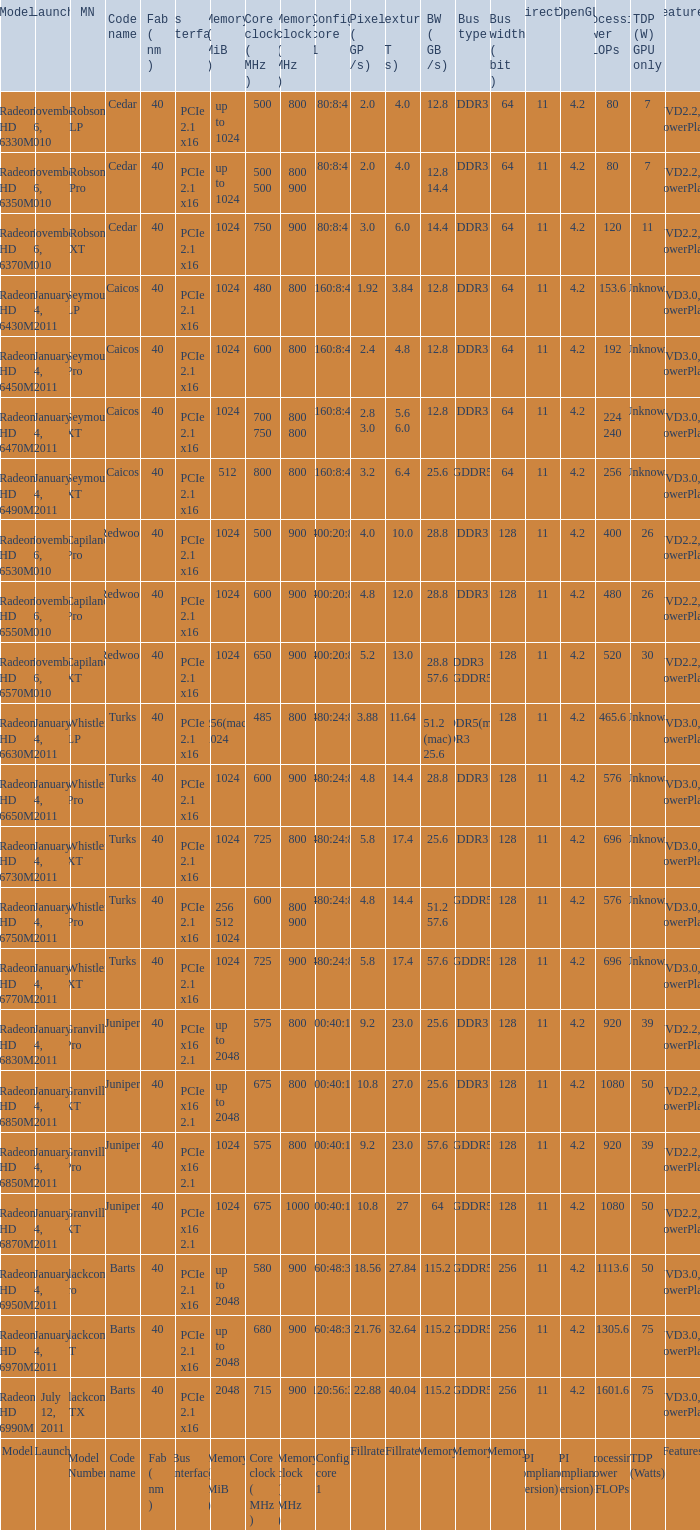Parse the full table. {'header': ['Model', 'Launch', 'MN', 'Code name', 'Fab ( nm )', 'Bus interface', 'Memory ( MiB )', 'Core clock ( MHz )', 'Memory clock ( MHz )', 'Config core 1', 'Pixel ( GP /s)', 'Texture ( GT /s)', 'BW ( GB /s)', 'Bus type', 'Bus width ( bit )', 'DirectX', 'OpenGL', 'Processing Power GFLOPs', 'TDP (W) GPU only', 'Features'], 'rows': [['Radeon HD 6330M', 'November 26, 2010', 'Robson LP', 'Cedar', '40', 'PCIe 2.1 x16', 'up to 1024', '500', '800', '80:8:4', '2.0', '4.0', '12.8', 'DDR3', '64', '11', '4.2', '80', '7', 'UVD2.2, PowerPlay'], ['Radeon HD 6350M', 'November 26, 2010', 'Robson Pro', 'Cedar', '40', 'PCIe 2.1 x16', 'up to 1024', '500 500', '800 900', '80:8:4', '2.0', '4.0', '12.8 14.4', 'DDR3', '64', '11', '4.2', '80', '7', 'UVD2.2, PowerPlay'], ['Radeon HD 6370M', 'November 26, 2010', 'Robson XT', 'Cedar', '40', 'PCIe 2.1 x16', '1024', '750', '900', '80:8:4', '3.0', '6.0', '14.4', 'DDR3', '64', '11', '4.2', '120', '11', 'UVD2.2, PowerPlay'], ['Radeon HD 6430M', 'January 4, 2011', 'Seymour LP', 'Caicos', '40', 'PCIe 2.1 x16', '1024', '480', '800', '160:8:4', '1.92', '3.84', '12.8', 'DDR3', '64', '11', '4.2', '153.6', 'Unknown', 'UVD3.0, PowerPlay'], ['Radeon HD 6450M', 'January 4, 2011', 'Seymour Pro', 'Caicos', '40', 'PCIe 2.1 x16', '1024', '600', '800', '160:8:4', '2.4', '4.8', '12.8', 'DDR3', '64', '11', '4.2', '192', 'Unknown', 'UVD3.0, PowerPlay'], ['Radeon HD 6470M', 'January 4, 2011', 'Seymour XT', 'Caicos', '40', 'PCIe 2.1 x16', '1024', '700 750', '800 800', '160:8:4', '2.8 3.0', '5.6 6.0', '12.8', 'DDR3', '64', '11', '4.2', '224 240', 'Unknown', 'UVD3.0, PowerPlay'], ['Radeon HD 6490M', 'January 4, 2011', 'Seymour XT', 'Caicos', '40', 'PCIe 2.1 x16', '512', '800', '800', '160:8:4', '3.2', '6.4', '25.6', 'GDDR5', '64', '11', '4.2', '256', 'Unknown', 'UVD3.0, PowerPlay'], ['Radeon HD 6530M', 'November 26, 2010', 'Capilano Pro', 'Redwood', '40', 'PCIe 2.1 x16', '1024', '500', '900', '400:20:8', '4.0', '10.0', '28.8', 'DDR3', '128', '11', '4.2', '400', '26', 'UVD2.2, PowerPlay'], ['Radeon HD 6550M', 'November 26, 2010', 'Capilano Pro', 'Redwood', '40', 'PCIe 2.1 x16', '1024', '600', '900', '400:20:8', '4.8', '12.0', '28.8', 'DDR3', '128', '11', '4.2', '480', '26', 'UVD2.2, PowerPlay'], ['Radeon HD 6570M', 'November 26, 2010', 'Capilano XT', 'Redwood', '40', 'PCIe 2.1 x16', '1024', '650', '900', '400:20:8', '5.2', '13.0', '28.8 57.6', 'DDR3 GDDR5', '128', '11', '4.2', '520', '30', 'UVD2.2, PowerPlay'], ['Radeon HD 6630M', 'January 4, 2011', 'Whistler LP', 'Turks', '40', 'PCIe 2.1 x16', '256(mac) 1024', '485', '800', '480:24:8', '3.88', '11.64', '51.2 (mac) 25.6', 'GDDR5(mac) DDR3', '128', '11', '4.2', '465.6', 'Unknown', 'UVD3.0, PowerPlay'], ['Radeon HD 6650M', 'January 4, 2011', 'Whistler Pro', 'Turks', '40', 'PCIe 2.1 x16', '1024', '600', '900', '480:24:8', '4.8', '14.4', '28.8', 'DDR3', '128', '11', '4.2', '576', 'Unknown', 'UVD3.0, PowerPlay'], ['Radeon HD 6730M', 'January 4, 2011', 'Whistler XT', 'Turks', '40', 'PCIe 2.1 x16', '1024', '725', '800', '480:24:8', '5.8', '17.4', '25.6', 'DDR3', '128', '11', '4.2', '696', 'Unknown', 'UVD3.0, PowerPlay'], ['Radeon HD 6750M', 'January 4, 2011', 'Whistler Pro', 'Turks', '40', 'PCIe 2.1 x16', '256 512 1024', '600', '800 900', '480:24:8', '4.8', '14.4', '51.2 57.6', 'GDDR5', '128', '11', '4.2', '576', 'Unknown', 'UVD3.0, PowerPlay'], ['Radeon HD 6770M', 'January 4, 2011', 'Whistler XT', 'Turks', '40', 'PCIe 2.1 x16', '1024', '725', '900', '480:24:8', '5.8', '17.4', '57.6', 'GDDR5', '128', '11', '4.2', '696', 'Unknown', 'UVD3.0, PowerPlay'], ['Radeon HD 6830M', 'January 4, 2011', 'Granville Pro', 'Juniper', '40', 'PCIe x16 2.1', 'up to 2048', '575', '800', '800:40:16', '9.2', '23.0', '25.6', 'DDR3', '128', '11', '4.2', '920', '39', 'UVD2.2, PowerPlay'], ['Radeon HD 6850M', 'January 4, 2011', 'Granville XT', 'Juniper', '40', 'PCIe x16 2.1', 'up to 2048', '675', '800', '800:40:16', '10.8', '27.0', '25.6', 'DDR3', '128', '11', '4.2', '1080', '50', 'UVD2.2, PowerPlay'], ['Radeon HD 6850M', 'January 4, 2011', 'Granville Pro', 'Juniper', '40', 'PCIe x16 2.1', '1024', '575', '800', '800:40:16', '9.2', '23.0', '57.6', 'GDDR5', '128', '11', '4.2', '920', '39', 'UVD2.2, PowerPlay'], ['Radeon HD 6870M', 'January 4, 2011', 'Granville XT', 'Juniper', '40', 'PCIe x16 2.1', '1024', '675', '1000', '800:40:16', '10.8', '27', '64', 'GDDR5', '128', '11', '4.2', '1080', '50', 'UVD2.2, PowerPlay'], ['Radeon HD 6950M', 'January 4, 2011', 'Blackcomb Pro', 'Barts', '40', 'PCIe 2.1 x16', 'up to 2048', '580', '900', '960:48:32', '18.56', '27.84', '115.2', 'GDDR5', '256', '11', '4.2', '1113.6', '50', 'UVD3.0, PowerPlay'], ['Radeon HD 6970M', 'January 4, 2011', 'Blackcomb XT', 'Barts', '40', 'PCIe 2.1 x16', 'up to 2048', '680', '900', '960:48:32', '21.76', '32.64', '115.2', 'GDDR5', '256', '11', '4.2', '1305.6', '75', 'UVD3.0, PowerPlay'], ['Radeon HD 6990M', 'July 12, 2011', 'Blackcomb XTX', 'Barts', '40', 'PCIe 2.1 x16', '2048', '715', '900', '1120:56:32', '22.88', '40.04', '115.2', 'GDDR5', '256', '11', '4.2', '1601.6', '75', 'UVD3.0, PowerPlay'], ['Model', 'Launch', 'Model Number', 'Code name', 'Fab ( nm )', 'Bus interface', 'Memory ( MiB )', 'Core clock ( MHz )', 'Memory clock ( MHz )', 'Config core 1', 'Fillrate', 'Fillrate', 'Memory', 'Memory', 'Memory', 'API compliance (version)', 'API compliance (version)', 'Processing Power GFLOPs', 'TDP (Watts)', 'Features']]} What is every bus type for the texture of fillrate? Memory. 